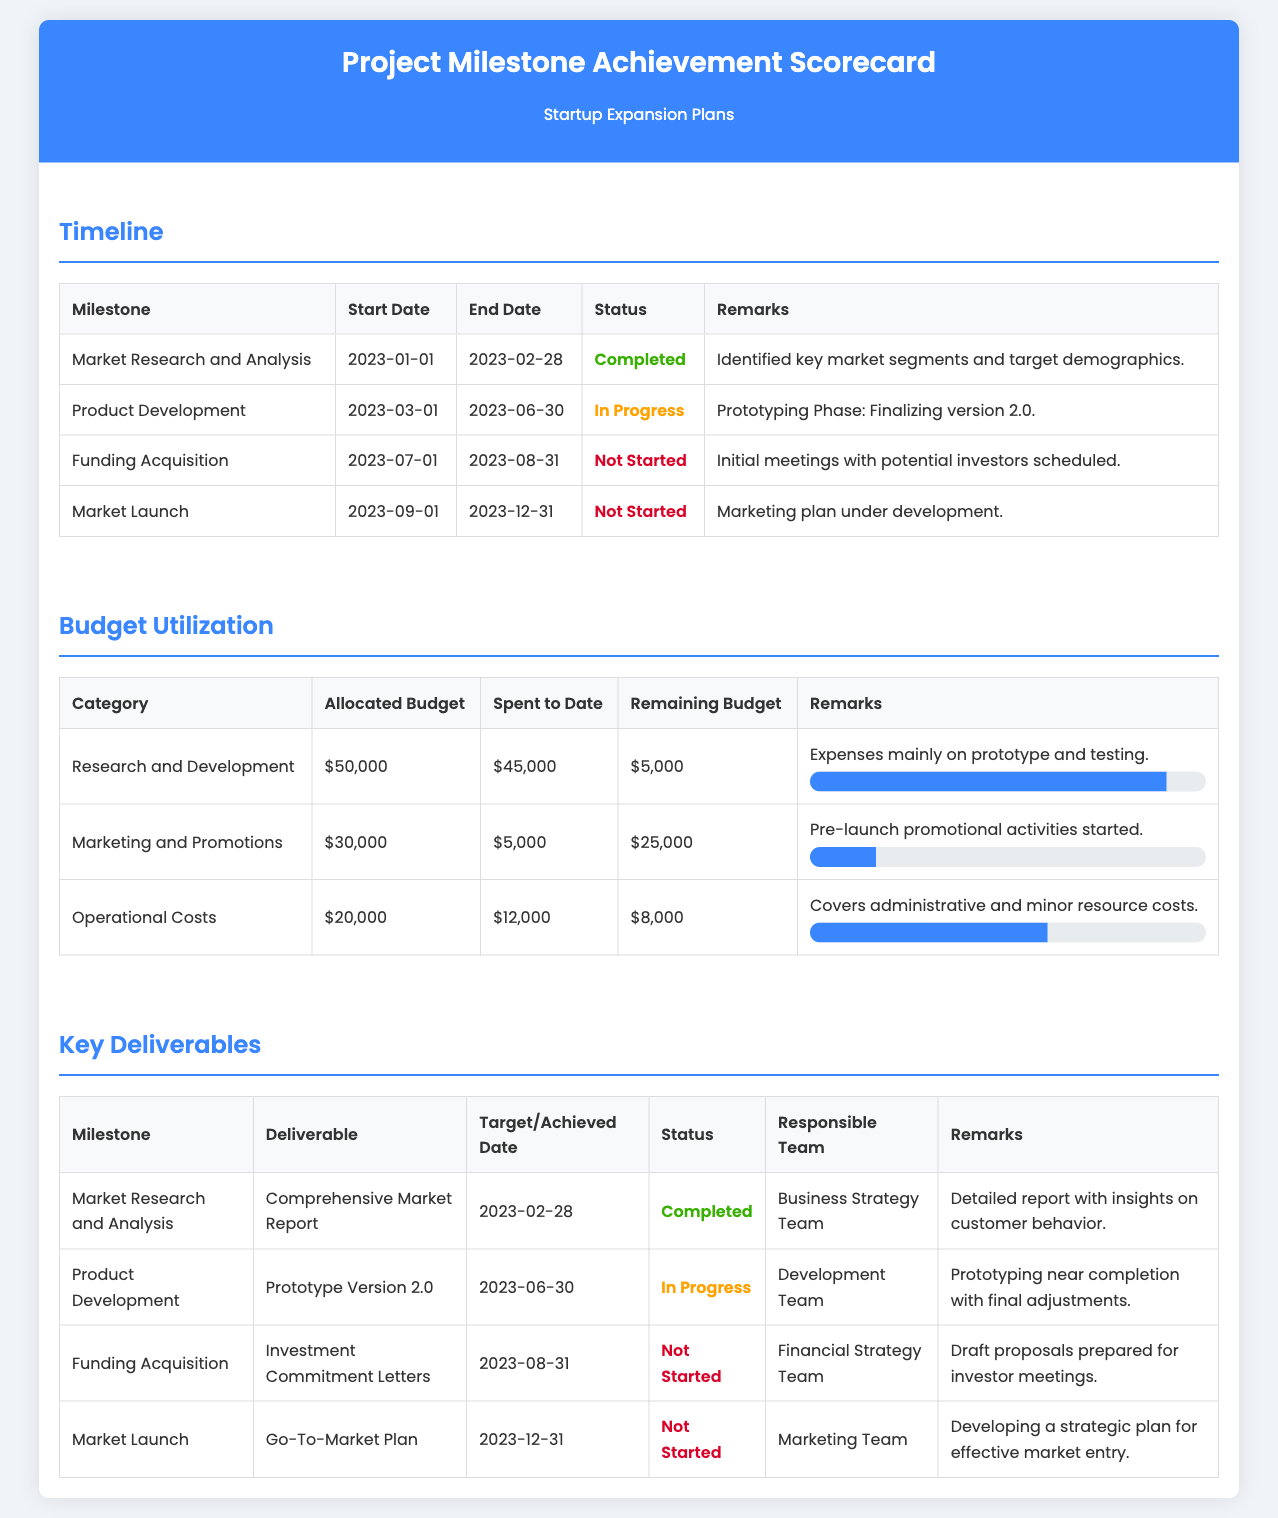what is the end date for Market Research and Analysis? The end date for Market Research and Analysis is specified in the table as 2023-02-28.
Answer: 2023-02-28 what is the status of Product Development? The status of Product Development is indicated as "In Progress" in the timeline section of the document.
Answer: In Progress how much of the budget has been spent in Marketing and Promotions? The document states that the amount spent to date in Marketing and Promotions is $5,000.
Answer: $5,000 who is responsible for the Go-To-Market Plan? The table for Key Deliverables shows that the Marketing Team is responsible for the Go-To-Market Plan.
Answer: Marketing Team what is the target date for Funding Acquisition? The target date for Funding Acquisition is provided in the table as 2023-08-31.
Answer: 2023-08-31 how much is the remaining budget for Research and Development? The remaining budget for Research and Development is listed as $5,000 in the budget utilization section.
Answer: $5,000 what was the deliverable for Market Research and Analysis? The deliverable for Market Research and Analysis is specified as the "Comprehensive Market Report" in the Key Deliverables table.
Answer: Comprehensive Market Report how many milestones are marked as "Not Started"? The timeline section shows 3 milestones marked as "Not Started".
Answer: 3 